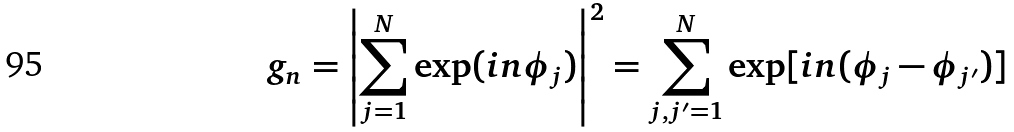Convert formula to latex. <formula><loc_0><loc_0><loc_500><loc_500>g _ { n } = \left | \sum _ { j = 1 } ^ { N } \exp ( i n \phi _ { j } ) \right | ^ { 2 } = \sum _ { j , j ^ { \prime } = 1 } ^ { N } \exp [ i n ( \phi _ { j } - \phi _ { j ^ { \prime } } ) ]</formula> 